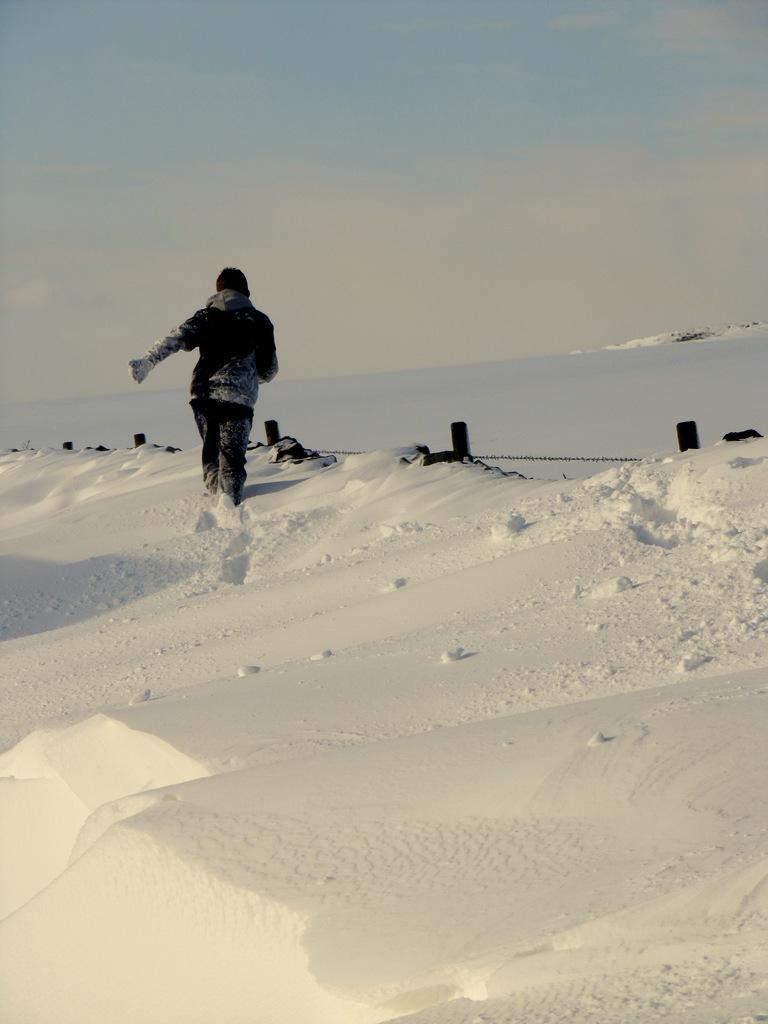In one or two sentences, can you explain what this image depicts? In this image I can see a man is walking on the snow. Here I can see a fence. In the background I can see the sky. 